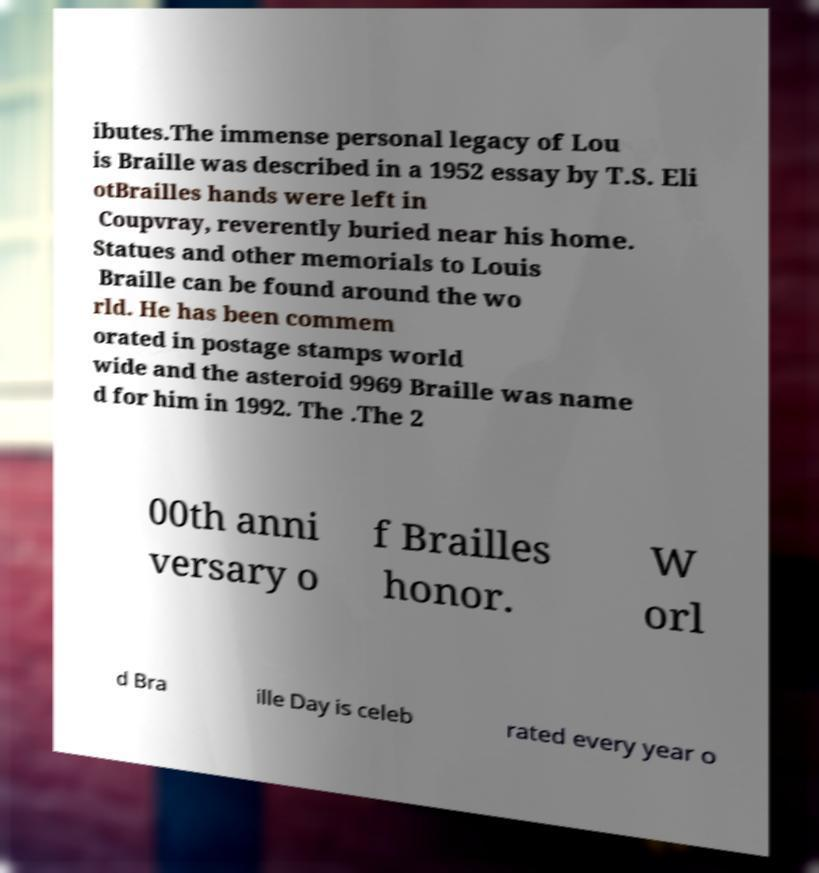I need the written content from this picture converted into text. Can you do that? ibutes.The immense personal legacy of Lou is Braille was described in a 1952 essay by T.S. Eli otBrailles hands were left in Coupvray, reverently buried near his home. Statues and other memorials to Louis Braille can be found around the wo rld. He has been commem orated in postage stamps world wide and the asteroid 9969 Braille was name d for him in 1992. The .The 2 00th anni versary o f Brailles honor. W orl d Bra ille Day is celeb rated every year o 